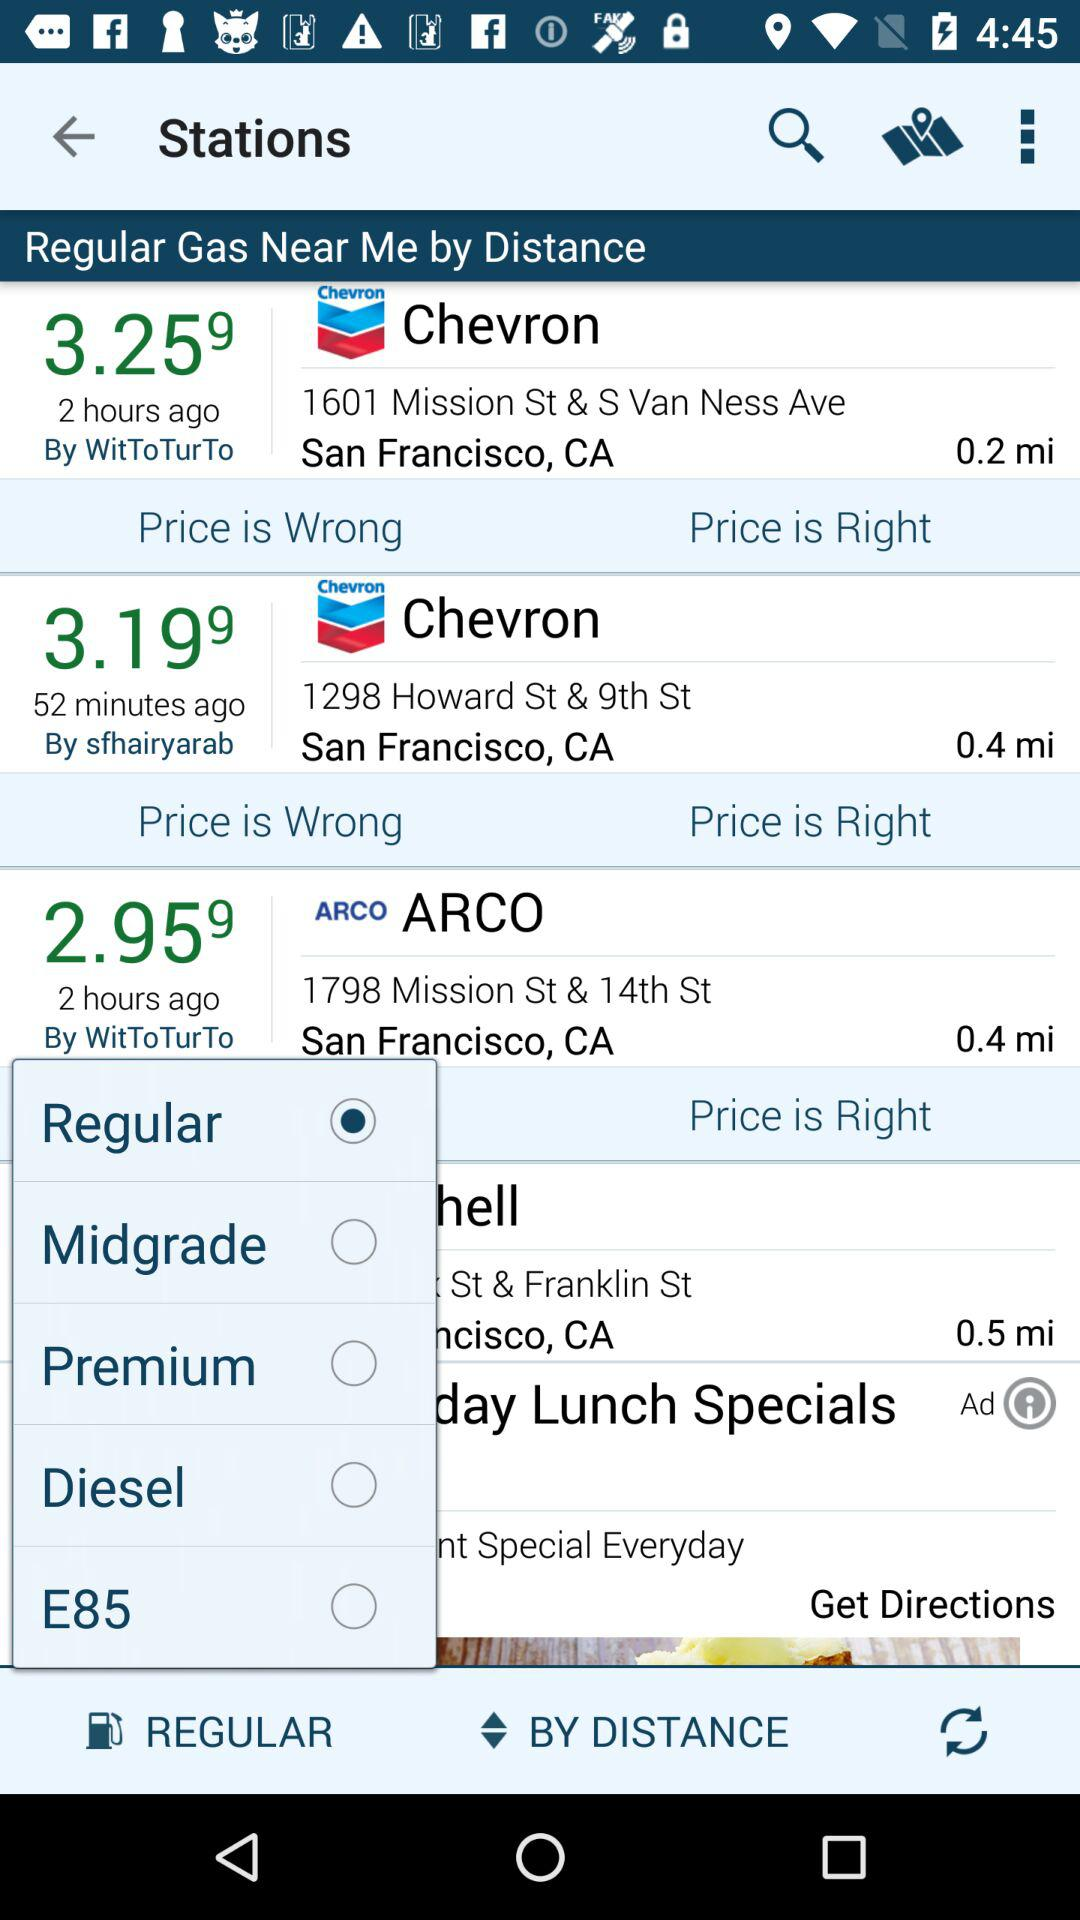Which option is selected? The selected option is "Regular". 